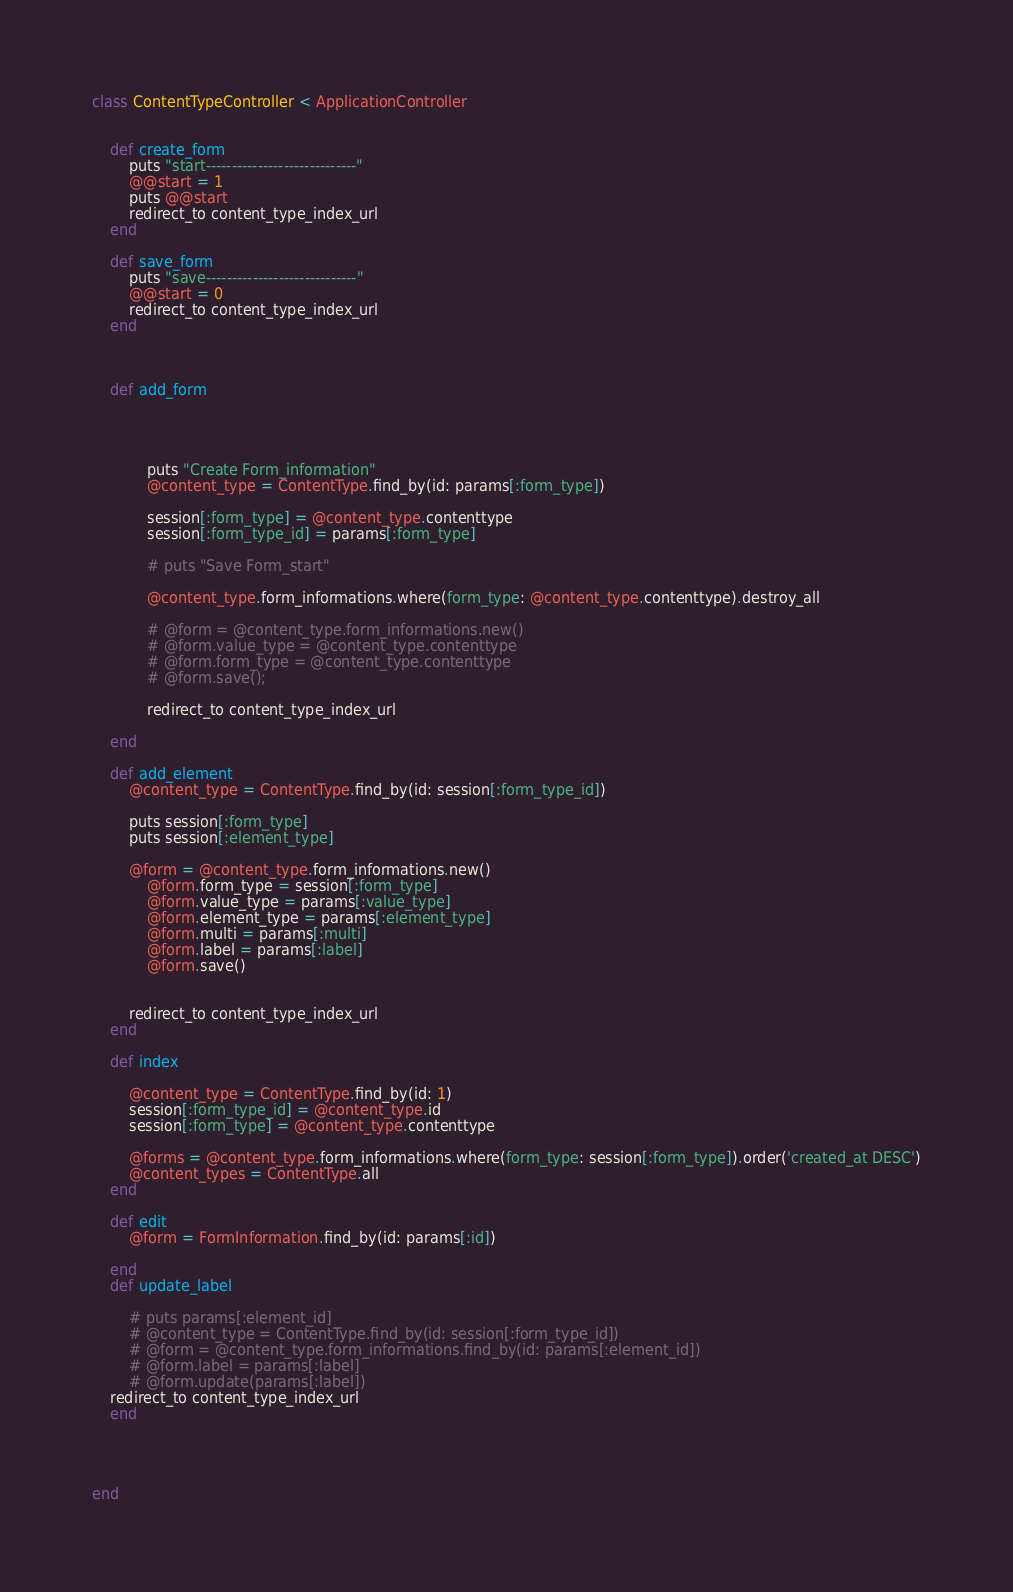Convert code to text. <code><loc_0><loc_0><loc_500><loc_500><_Ruby_>class ContentTypeController < ApplicationController


	def create_form
		puts "start-----------------------------"
    	@@start = 1
    	puts @@start
		redirect_to content_type_index_url
	end

	def save_form
		puts "save-----------------------------"
    	@@start = 0
		redirect_to content_type_index_url
	end



	def add_form
	
		

		
			puts "Create Form_information"
			@content_type = ContentType.find_by(id: params[:form_type])

			session[:form_type] = @content_type.contenttype
			session[:form_type_id] = params[:form_type]

			# puts "Save Form_start"
			
			@content_type.form_informations.where(form_type: @content_type.contenttype).destroy_all
			
			# @form = @content_type.form_informations.new()
			# @form.value_type = @content_type.contenttype
			# @form.form_type = @content_type.contenttype
			# @form.save();	
			
			redirect_to content_type_index_url
		
    end

    def add_element
    	@content_type = ContentType.find_by(id: session[:form_type_id])

    	puts session[:form_type]
    	puts session[:element_type]

     	@form = @content_type.form_informations.new()
			@form.form_type = session[:form_type]
			@form.value_type = params[:value_type]
			@form.element_type = params[:element_type]
			@form.multi = params[:multi]
			@form.label = params[:label]
			@form.save()	

		
    	redirect_to content_type_index_url
    end

    def index
    
    	@content_type = ContentType.find_by(id: 1)
    	session[:form_type_id] = @content_type.id
    	session[:form_type] = @content_type.contenttype

    	@forms = @content_type.form_informations.where(form_type: session[:form_type]).order('created_at DESC')
        @content_types = ContentType.all 
    end

    def edit
    	@form = FormInformation.find_by(id: params[:id])
    	
    end
    def update_label
    	
		# puts params[:element_id]
		# @content_type = ContentType.find_by(id: session[:form_type_id])
		# @form = @content_type.form_informations.find_by(id: params[:element_id])
		# @form.label = params[:label]
		# @form.update(params[:label])
    redirect_to content_type_index_url
    end

    
   	

end
</code> 